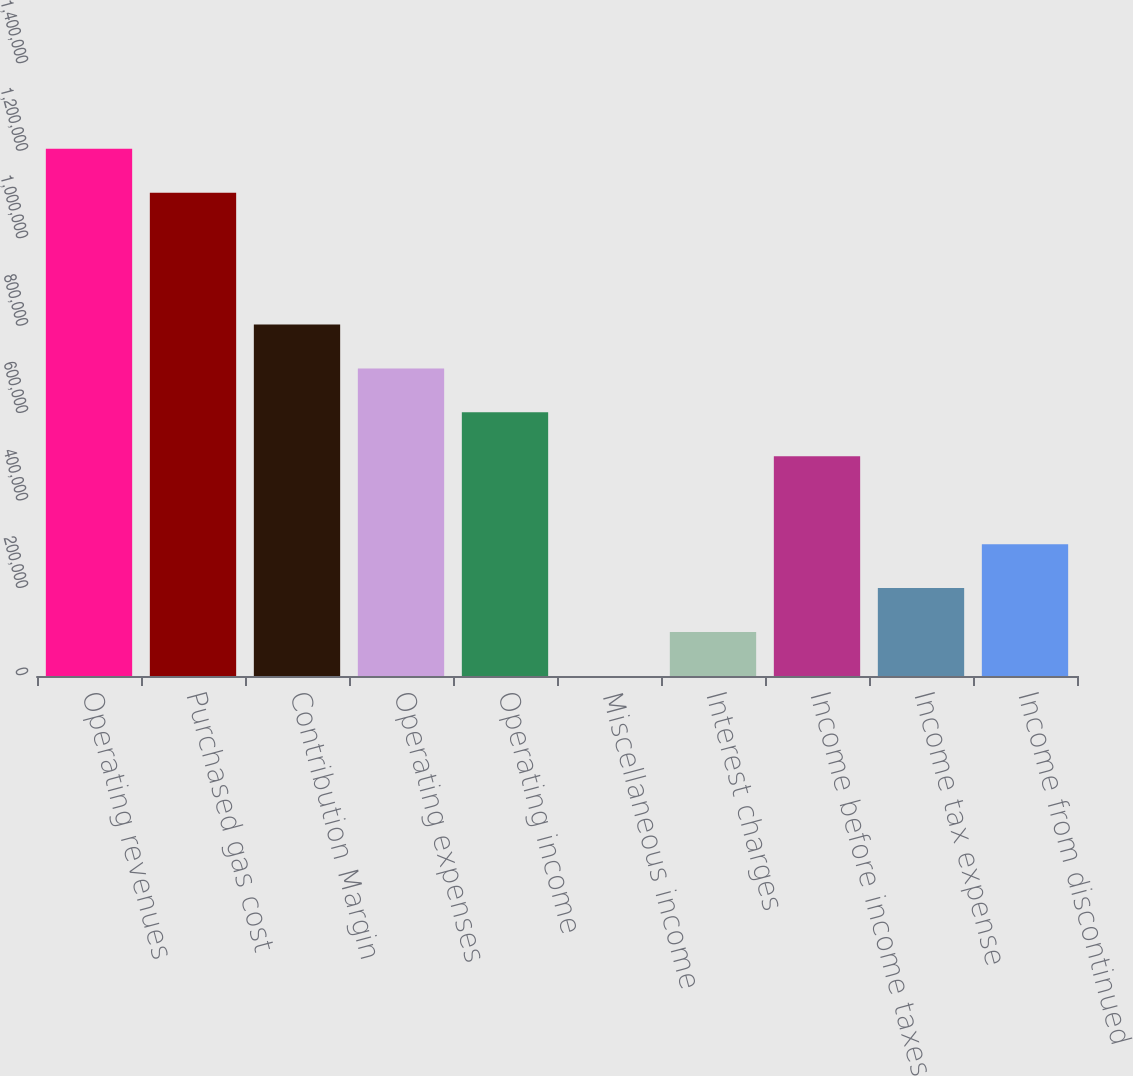Convert chart to OTSL. <chart><loc_0><loc_0><loc_500><loc_500><bar_chart><fcel>Operating revenues<fcel>Purchased gas cost<fcel>Contribution Margin<fcel>Operating expenses<fcel>Operating income<fcel>Miscellaneous income<fcel>Interest charges<fcel>Income before income taxes<fcel>Income tax expense<fcel>Income from discontinued<nl><fcel>1.20609e+06<fcel>1.10559e+06<fcel>804094<fcel>703596<fcel>603098<fcel>109<fcel>100607<fcel>502600<fcel>201105<fcel>301603<nl></chart> 